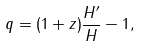<formula> <loc_0><loc_0><loc_500><loc_500>q = ( 1 + z ) \frac { H ^ { \prime } } { H } - 1 ,</formula> 